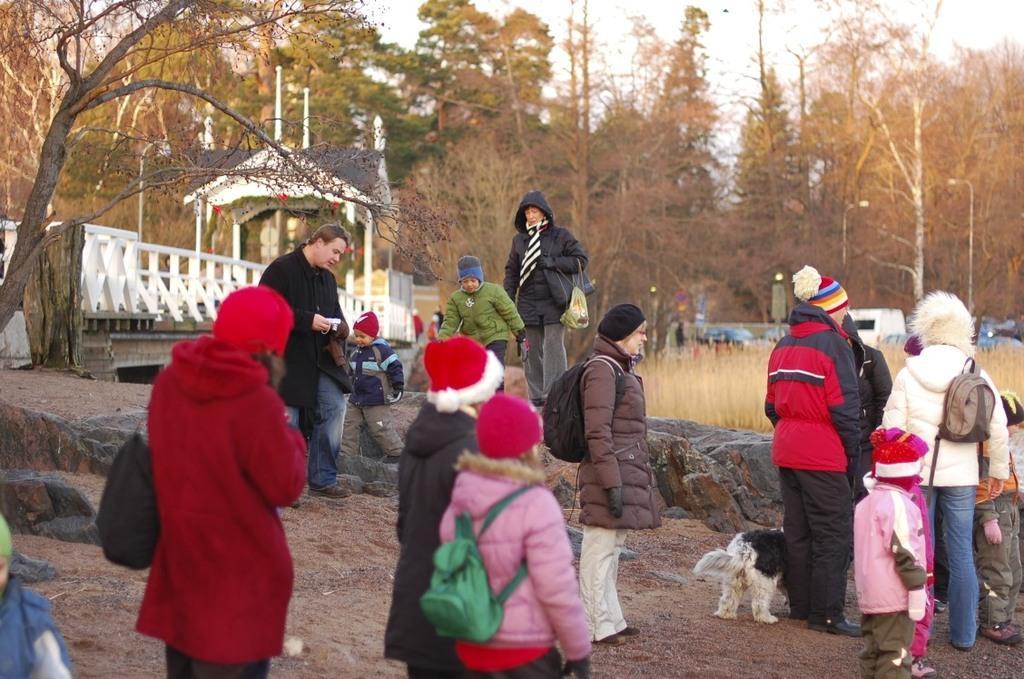Describe this image in one or two sentences. In this image, we can see people wearing coats and there is a dog, at the bottom. In the background, there are trees and there is a bridge. 